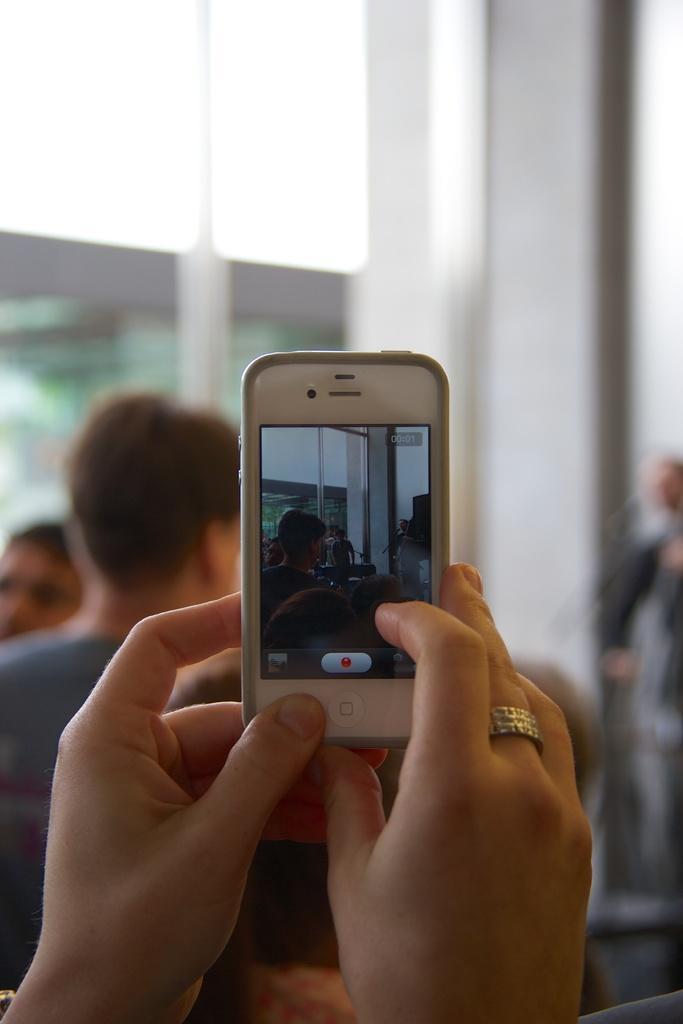Describe this image in one or two sentences. this picture shows a person holding mobile in hands and taking a picture and we see few people seated in front 